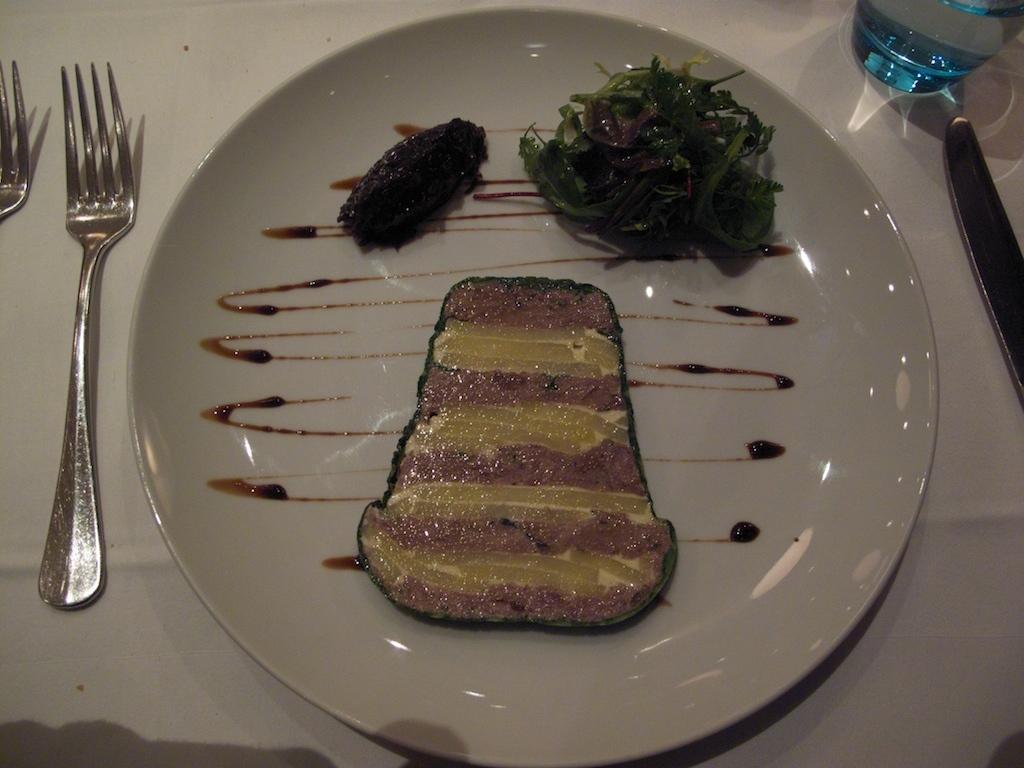In one or two sentences, can you explain what this image depicts? In this image there is a food item on the plate, beside the plate there are two forks and on the other side there is a knife and a bottle are arranged on the table. 